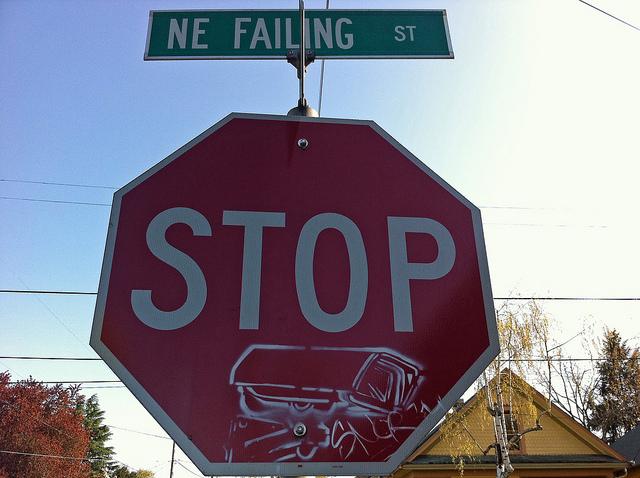What colors of paint did the graffiti artist use?
Answer briefly. White. Is it late afternoon?
Be succinct. Yes. What sign is this?
Be succinct. Stop. How many signs are on the post?
Be succinct. 2. What is the length of the sign?
Answer briefly. 12 inches. What street was this picture taken?
Quick response, please. Ne failing st. What drawing is on the sign?
Give a very brief answer. Camera. 